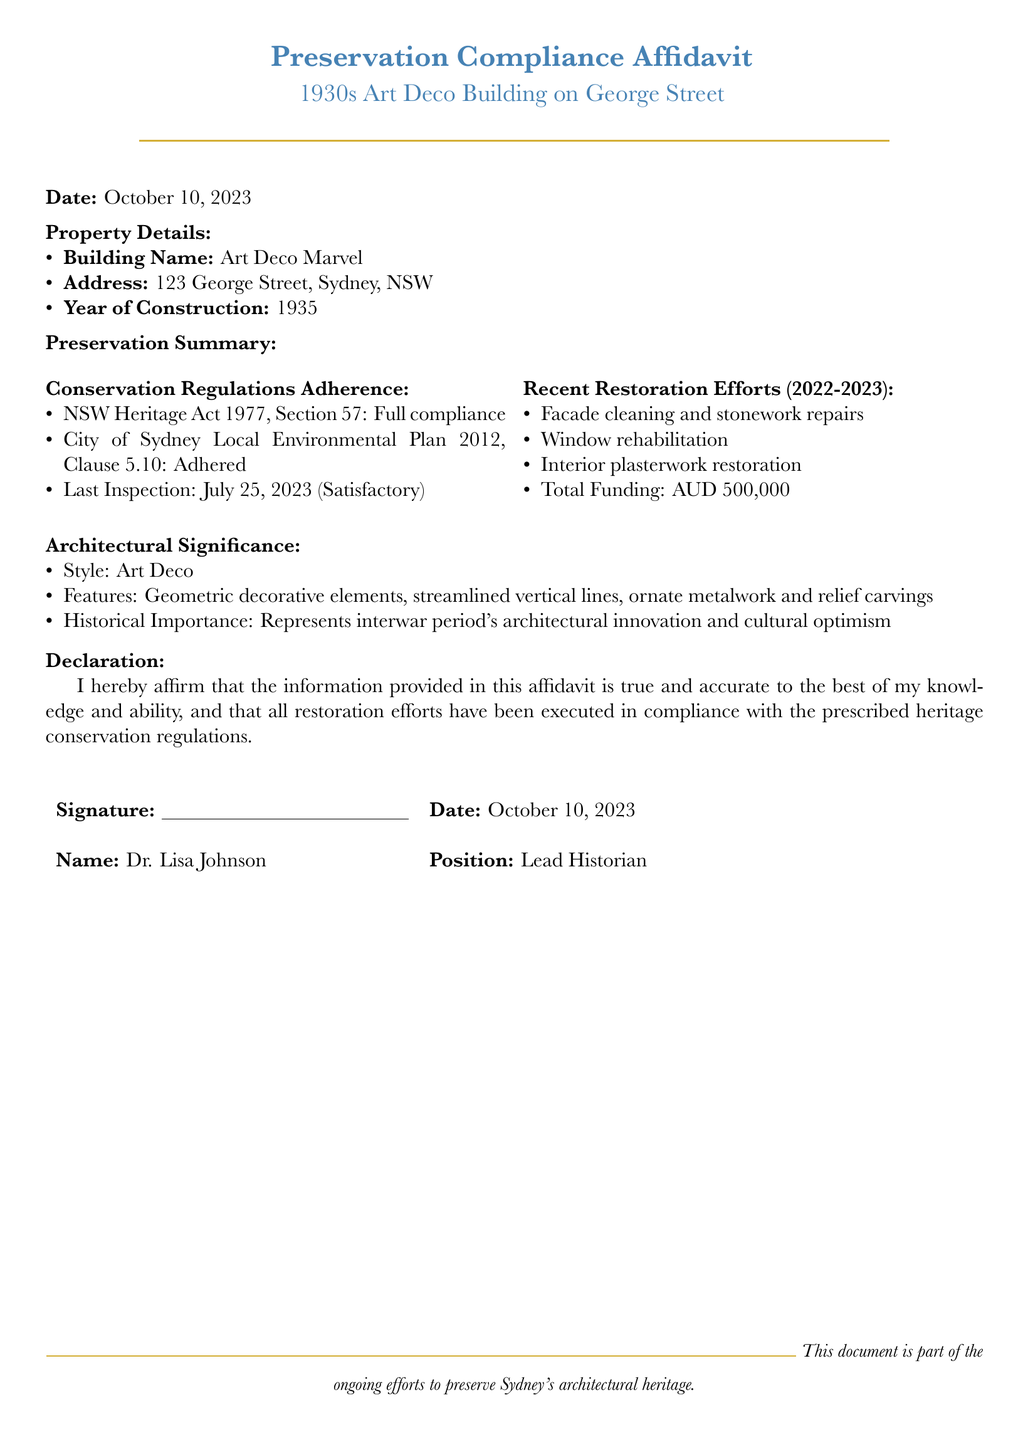what is the building name? The building name is listed under Property Details in the document.
Answer: Art Deco Marvel what year was the building constructed? The year of construction is stated in the Property Details section.
Answer: 1935 what is the total funding for the restoration efforts? The total funding amount is provided in the Recent Restoration Efforts section of the document.
Answer: AUD 500,000 when was the last inspection conducted? The last inspection date is mentioned in the Conservation Regulations Adherence section.
Answer: July 25, 2023 what architectural style is the building known for? The architectural style is detailed in the Architectural Significance section.
Answer: Art Deco how many restoration efforts are listed in the document? The number of items in the Recent Restoration Efforts section indicates the efforts made.
Answer: Four who signed the affidavit? The name of the signatory is found in the Declaration section.
Answer: Dr. Lisa Johnson what regulations does the preservation affidavit comply with? The compliance information is outlined in the Conservation Regulations Adherence section.
Answer: NSW Heritage Act 1977, Section 57 why is the building historically important? The historical importance is explained in the Architectural Significance section.
Answer: Represents interwar period's architectural innovation and cultural optimism 